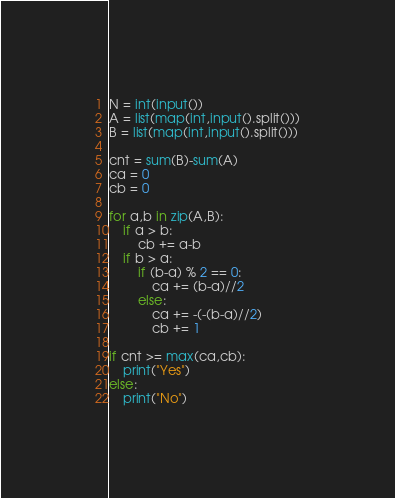Convert code to text. <code><loc_0><loc_0><loc_500><loc_500><_Python_>N = int(input())
A = list(map(int,input().split()))
B = list(map(int,input().split()))

cnt = sum(B)-sum(A)
ca = 0
cb = 0

for a,b in zip(A,B):
    if a > b:
        cb += a-b
    if b > a:
        if (b-a) % 2 == 0:
            ca += (b-a)//2
        else:
            ca += -(-(b-a)//2)
            cb += 1

if cnt >= max(ca,cb):
    print("Yes")
else:
    print("No")</code> 